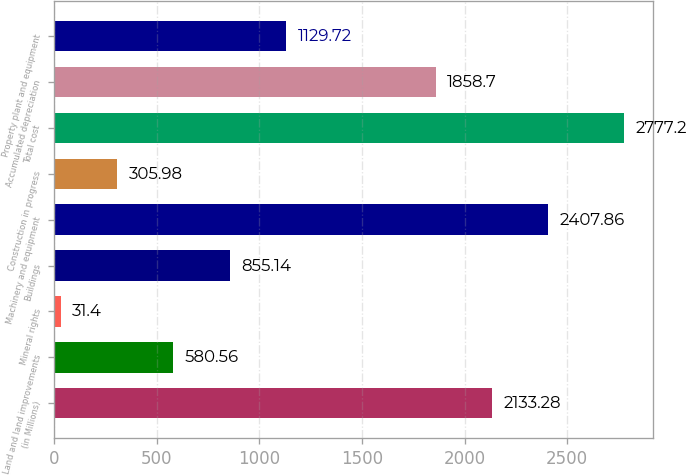Convert chart to OTSL. <chart><loc_0><loc_0><loc_500><loc_500><bar_chart><fcel>(in Millions)<fcel>Land and land improvements<fcel>Mineral rights<fcel>Buildings<fcel>Machinery and equipment<fcel>Construction in progress<fcel>Total cost<fcel>Accumulated depreciation<fcel>Property plant and equipment<nl><fcel>2133.28<fcel>580.56<fcel>31.4<fcel>855.14<fcel>2407.86<fcel>305.98<fcel>2777.2<fcel>1858.7<fcel>1129.72<nl></chart> 